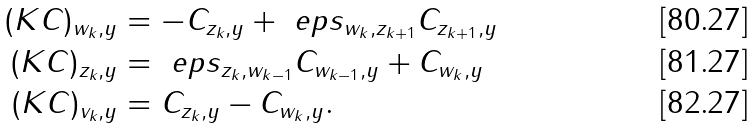Convert formula to latex. <formula><loc_0><loc_0><loc_500><loc_500>( K C ) _ { w _ { k } , y } & = - C _ { z _ { k } , y } + \ e p s _ { w _ { k } , z _ { k + 1 } } C _ { z _ { k + 1 } , y } \\ ( K C ) _ { z _ { k } , y } & = \ e p s _ { z _ { k } , w _ { k - 1 } } C _ { w _ { k - 1 } , y } + C _ { w _ { k } , y } \\ ( K C ) _ { v _ { k } , y } & = C _ { z _ { k } , y } - C _ { w _ { k } , y } .</formula> 